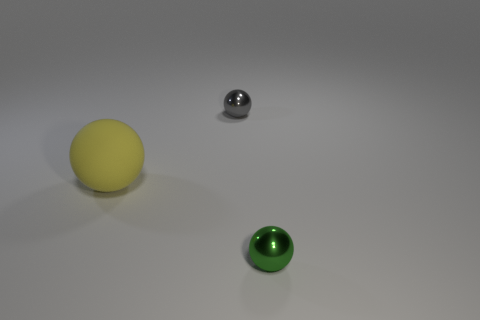Subtract all big spheres. How many spheres are left? 2 Add 2 red matte things. How many objects exist? 5 Subtract 1 spheres. How many spheres are left? 2 Subtract 1 gray spheres. How many objects are left? 2 Subtract all blue spheres. Subtract all gray cylinders. How many spheres are left? 3 Subtract all blue cubes. How many purple balls are left? 0 Subtract all big yellow matte balls. Subtract all tiny yellow metal cylinders. How many objects are left? 2 Add 1 yellow things. How many yellow things are left? 2 Add 3 big gray matte blocks. How many big gray matte blocks exist? 3 